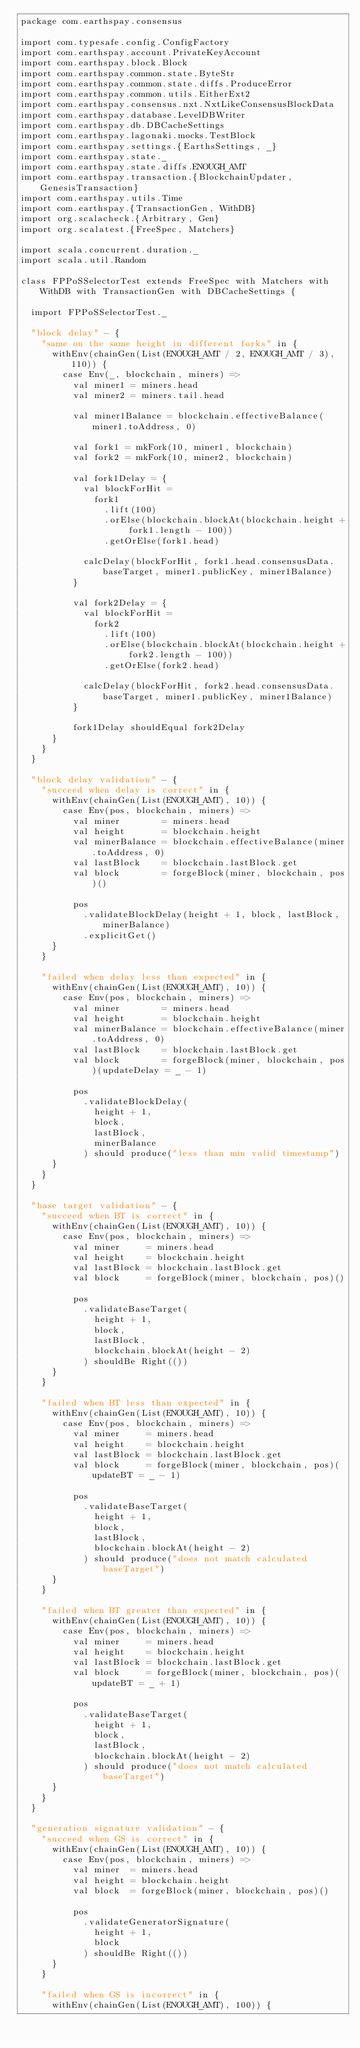Convert code to text. <code><loc_0><loc_0><loc_500><loc_500><_Scala_>package com.earthspay.consensus

import com.typesafe.config.ConfigFactory
import com.earthspay.account.PrivateKeyAccount
import com.earthspay.block.Block
import com.earthspay.common.state.ByteStr
import com.earthspay.common.state.diffs.ProduceError
import com.earthspay.common.utils.EitherExt2
import com.earthspay.consensus.nxt.NxtLikeConsensusBlockData
import com.earthspay.database.LevelDBWriter
import com.earthspay.db.DBCacheSettings
import com.earthspay.lagonaki.mocks.TestBlock
import com.earthspay.settings.{EarthsSettings, _}
import com.earthspay.state._
import com.earthspay.state.diffs.ENOUGH_AMT
import com.earthspay.transaction.{BlockchainUpdater, GenesisTransaction}
import com.earthspay.utils.Time
import com.earthspay.{TransactionGen, WithDB}
import org.scalacheck.{Arbitrary, Gen}
import org.scalatest.{FreeSpec, Matchers}

import scala.concurrent.duration._
import scala.util.Random

class FPPoSSelectorTest extends FreeSpec with Matchers with WithDB with TransactionGen with DBCacheSettings {

  import FPPoSSelectorTest._

  "block delay" - {
    "same on the same height in different forks" in {
      withEnv(chainGen(List(ENOUGH_AMT / 2, ENOUGH_AMT / 3), 110)) {
        case Env(_, blockchain, miners) =>
          val miner1 = miners.head
          val miner2 = miners.tail.head

          val miner1Balance = blockchain.effectiveBalance(miner1.toAddress, 0)

          val fork1 = mkFork(10, miner1, blockchain)
          val fork2 = mkFork(10, miner2, blockchain)

          val fork1Delay = {
            val blockForHit =
              fork1
                .lift(100)
                .orElse(blockchain.blockAt(blockchain.height + fork1.length - 100))
                .getOrElse(fork1.head)

            calcDelay(blockForHit, fork1.head.consensusData.baseTarget, miner1.publicKey, miner1Balance)
          }

          val fork2Delay = {
            val blockForHit =
              fork2
                .lift(100)
                .orElse(blockchain.blockAt(blockchain.height + fork2.length - 100))
                .getOrElse(fork2.head)

            calcDelay(blockForHit, fork2.head.consensusData.baseTarget, miner1.publicKey, miner1Balance)
          }

          fork1Delay shouldEqual fork2Delay
      }
    }
  }

  "block delay validation" - {
    "succeed when delay is correct" in {
      withEnv(chainGen(List(ENOUGH_AMT), 10)) {
        case Env(pos, blockchain, miners) =>
          val miner        = miners.head
          val height       = blockchain.height
          val minerBalance = blockchain.effectiveBalance(miner.toAddress, 0)
          val lastBlock    = blockchain.lastBlock.get
          val block        = forgeBlock(miner, blockchain, pos)()

          pos
            .validateBlockDelay(height + 1, block, lastBlock, minerBalance)
            .explicitGet()
      }
    }

    "failed when delay less than expected" in {
      withEnv(chainGen(List(ENOUGH_AMT), 10)) {
        case Env(pos, blockchain, miners) =>
          val miner        = miners.head
          val height       = blockchain.height
          val minerBalance = blockchain.effectiveBalance(miner.toAddress, 0)
          val lastBlock    = blockchain.lastBlock.get
          val block        = forgeBlock(miner, blockchain, pos)(updateDelay = _ - 1)

          pos
            .validateBlockDelay(
              height + 1,
              block,
              lastBlock,
              minerBalance
            ) should produce("less than min valid timestamp")
      }
    }
  }

  "base target validation" - {
    "succeed when BT is correct" in {
      withEnv(chainGen(List(ENOUGH_AMT), 10)) {
        case Env(pos, blockchain, miners) =>
          val miner     = miners.head
          val height    = blockchain.height
          val lastBlock = blockchain.lastBlock.get
          val block     = forgeBlock(miner, blockchain, pos)()

          pos
            .validateBaseTarget(
              height + 1,
              block,
              lastBlock,
              blockchain.blockAt(height - 2)
            ) shouldBe Right(())
      }
    }

    "failed when BT less than expected" in {
      withEnv(chainGen(List(ENOUGH_AMT), 10)) {
        case Env(pos, blockchain, miners) =>
          val miner     = miners.head
          val height    = blockchain.height
          val lastBlock = blockchain.lastBlock.get
          val block     = forgeBlock(miner, blockchain, pos)(updateBT = _ - 1)

          pos
            .validateBaseTarget(
              height + 1,
              block,
              lastBlock,
              blockchain.blockAt(height - 2)
            ) should produce("does not match calculated baseTarget")
      }
    }

    "failed when BT greater than expected" in {
      withEnv(chainGen(List(ENOUGH_AMT), 10)) {
        case Env(pos, blockchain, miners) =>
          val miner     = miners.head
          val height    = blockchain.height
          val lastBlock = blockchain.lastBlock.get
          val block     = forgeBlock(miner, blockchain, pos)(updateBT = _ + 1)

          pos
            .validateBaseTarget(
              height + 1,
              block,
              lastBlock,
              blockchain.blockAt(height - 2)
            ) should produce("does not match calculated baseTarget")
      }
    }
  }

  "generation signature validation" - {
    "succeed when GS is correct" in {
      withEnv(chainGen(List(ENOUGH_AMT), 10)) {
        case Env(pos, blockchain, miners) =>
          val miner  = miners.head
          val height = blockchain.height
          val block  = forgeBlock(miner, blockchain, pos)()

          pos
            .validateGeneratorSignature(
              height + 1,
              block
            ) shouldBe Right(())
      }
    }

    "failed when GS is incorrect" in {
      withEnv(chainGen(List(ENOUGH_AMT), 100)) {</code> 